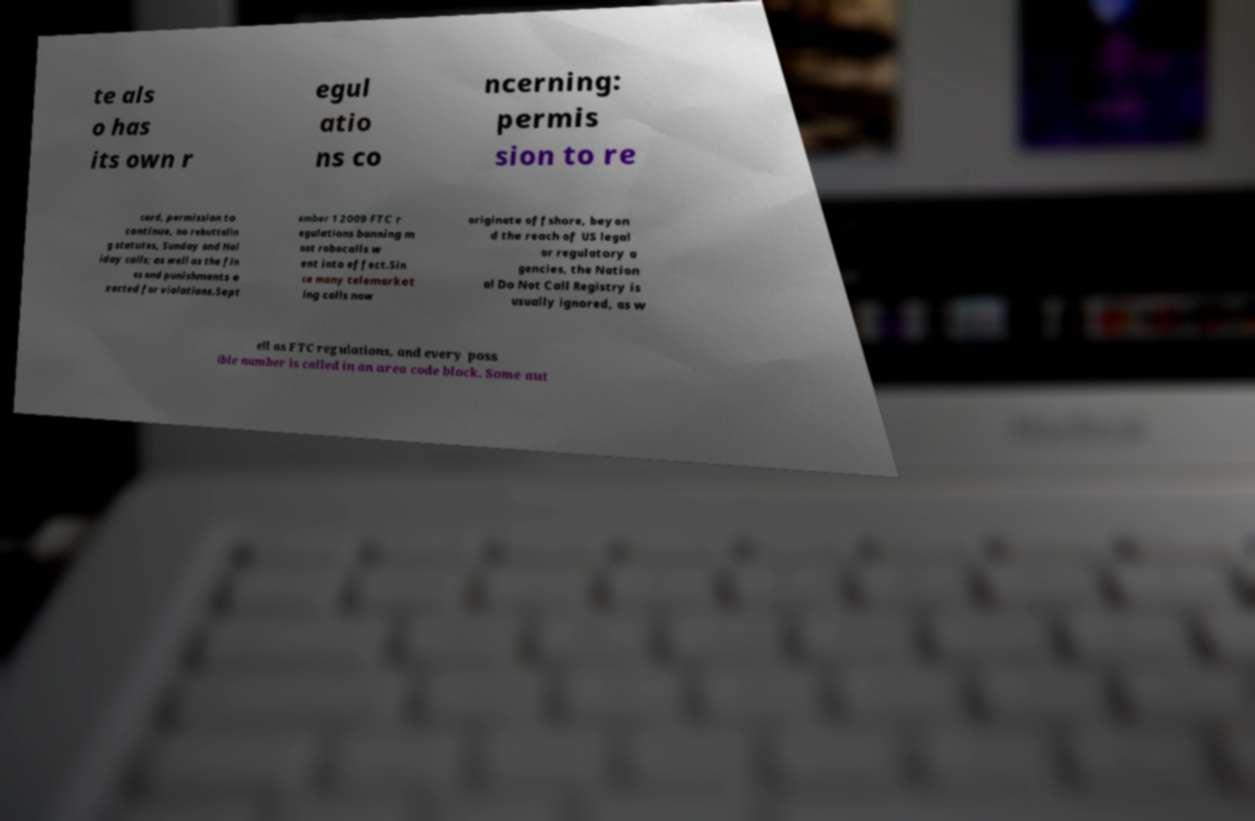Can you accurately transcribe the text from the provided image for me? te als o has its own r egul atio ns co ncerning: permis sion to re cord, permission to continue, no rebuttalin g statutes, Sunday and Hol iday calls; as well as the fin es and punishments e xacted for violations.Sept ember 1 2009 FTC r egulations banning m ost robocalls w ent into effect.Sin ce many telemarket ing calls now originate offshore, beyon d the reach of US legal or regulatory a gencies, the Nation al Do Not Call Registry is usually ignored, as w ell as FTC regulations, and every poss ible number is called in an area code block. Some aut 